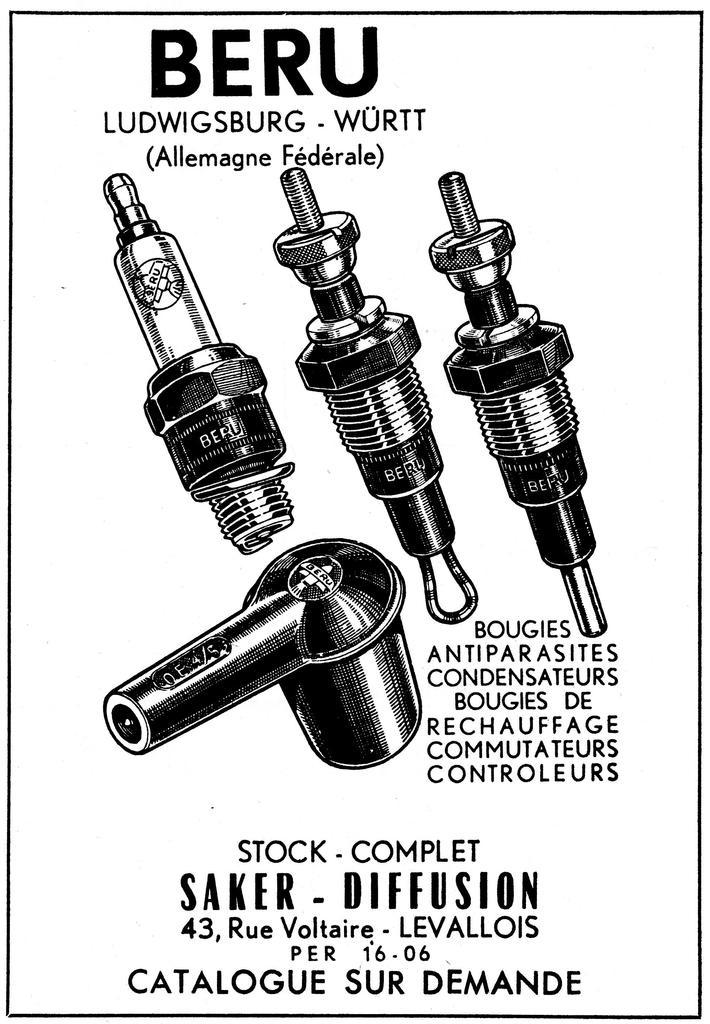What is the main subject of the image? The main subject of the image is a cover page. What can be seen on the top of the cover page? There is text on the top of the cover page. What can be seen on the bottom of the cover page? There is text on the bottom of the cover page. Are there any visual elements on the cover page besides text? Yes, there are photos of objects in the image. What type of pest can be seen crawling on the cord in the image? There is no cord or pest present in the image. How many pears are visible in the image? There are no pears present in the image. 